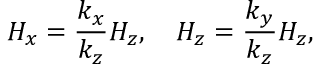<formula> <loc_0><loc_0><loc_500><loc_500>H _ { x } = \frac { k _ { x } } { k _ { z } } H _ { z } , \quad H _ { z } = \frac { k _ { y } } { k _ { z } } H _ { z } ,</formula> 